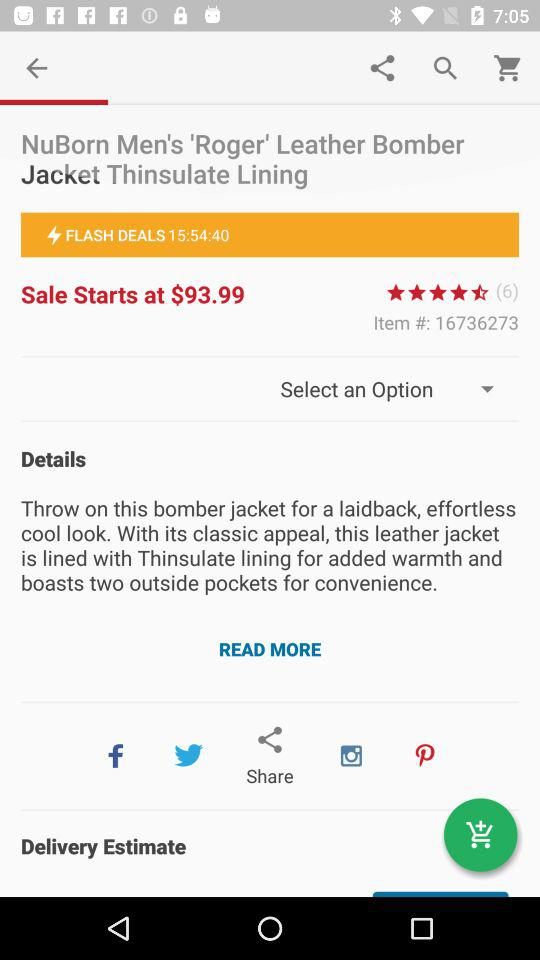How many ratings are there? There are 6 ratings. 